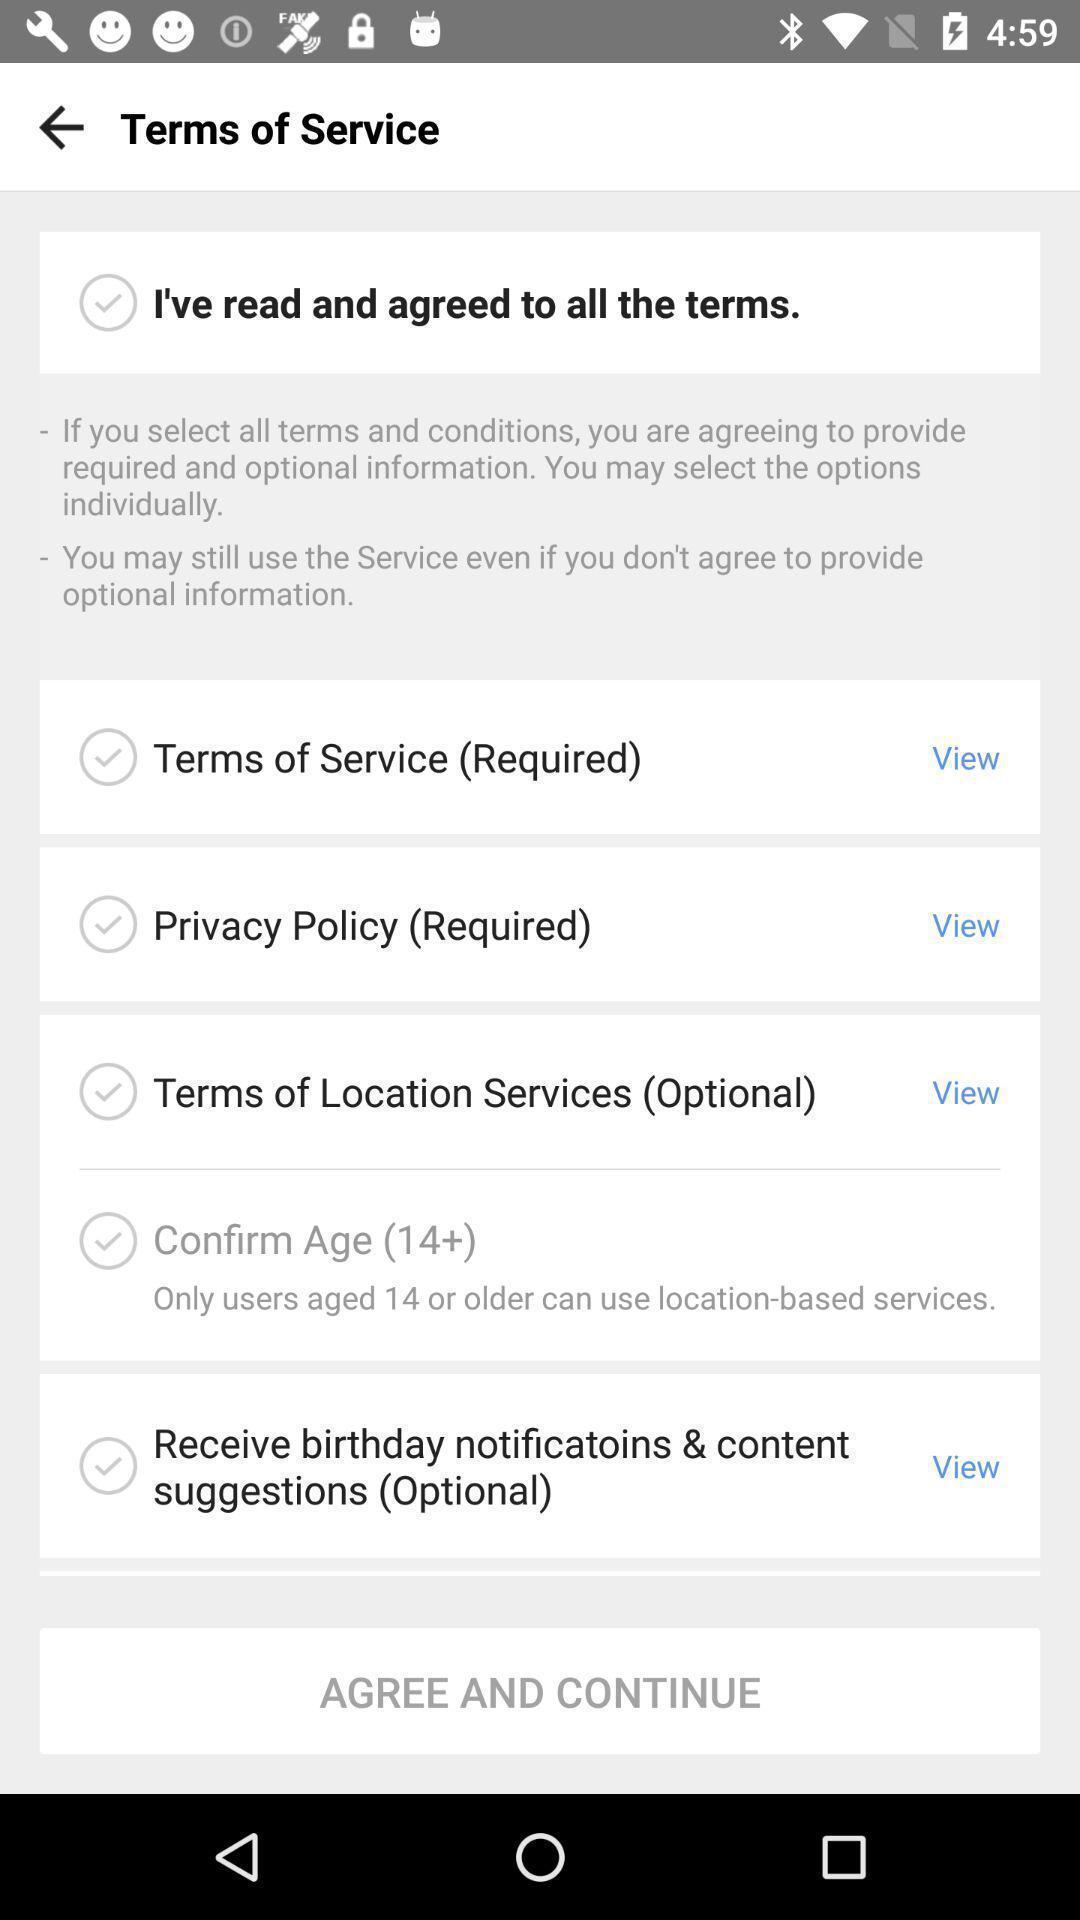Provide a textual representation of this image. Page displaying with list of services to view. 